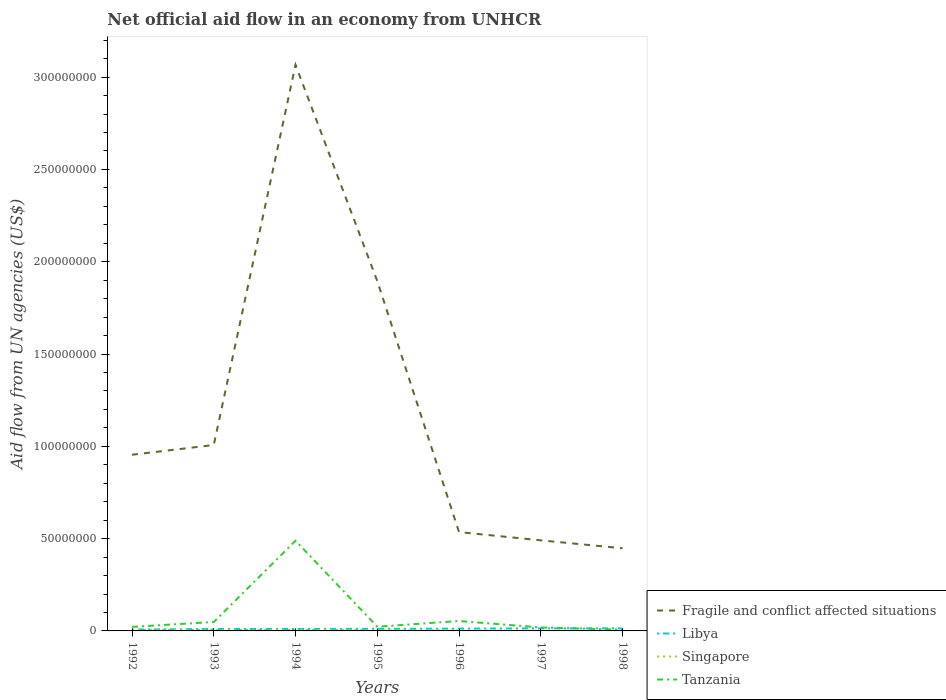Is the number of lines equal to the number of legend labels?
Your answer should be compact. Yes. Across all years, what is the maximum net official aid flow in Fragile and conflict affected situations?
Offer a very short reply. 4.48e+07. What is the total net official aid flow in Fragile and conflict affected situations in the graph?
Give a very brief answer. 4.19e+07. What is the difference between the highest and the second highest net official aid flow in Singapore?
Offer a terse response. 5.30e+05. Is the net official aid flow in Tanzania strictly greater than the net official aid flow in Singapore over the years?
Make the answer very short. No. How many lines are there?
Offer a very short reply. 4. Does the graph contain any zero values?
Make the answer very short. No. Does the graph contain grids?
Keep it short and to the point. No. How many legend labels are there?
Ensure brevity in your answer.  4. How are the legend labels stacked?
Keep it short and to the point. Vertical. What is the title of the graph?
Provide a succinct answer. Net official aid flow in an economy from UNHCR. What is the label or title of the X-axis?
Make the answer very short. Years. What is the label or title of the Y-axis?
Keep it short and to the point. Aid flow from UN agencies (US$). What is the Aid flow from UN agencies (US$) of Fragile and conflict affected situations in 1992?
Ensure brevity in your answer.  9.54e+07. What is the Aid flow from UN agencies (US$) in Libya in 1992?
Offer a terse response. 7.30e+05. What is the Aid flow from UN agencies (US$) in Singapore in 1992?
Your answer should be very brief. 6.00e+05. What is the Aid flow from UN agencies (US$) of Tanzania in 1992?
Ensure brevity in your answer.  2.19e+06. What is the Aid flow from UN agencies (US$) in Fragile and conflict affected situations in 1993?
Provide a succinct answer. 1.01e+08. What is the Aid flow from UN agencies (US$) in Libya in 1993?
Provide a short and direct response. 1.05e+06. What is the Aid flow from UN agencies (US$) in Tanzania in 1993?
Your answer should be compact. 4.85e+06. What is the Aid flow from UN agencies (US$) of Fragile and conflict affected situations in 1994?
Your answer should be compact. 3.07e+08. What is the Aid flow from UN agencies (US$) of Libya in 1994?
Your answer should be compact. 1.07e+06. What is the Aid flow from UN agencies (US$) of Singapore in 1994?
Keep it short and to the point. 5.80e+05. What is the Aid flow from UN agencies (US$) of Tanzania in 1994?
Offer a terse response. 4.89e+07. What is the Aid flow from UN agencies (US$) in Fragile and conflict affected situations in 1995?
Offer a very short reply. 1.90e+08. What is the Aid flow from UN agencies (US$) of Libya in 1995?
Your answer should be very brief. 1.13e+06. What is the Aid flow from UN agencies (US$) in Tanzania in 1995?
Provide a short and direct response. 2.28e+06. What is the Aid flow from UN agencies (US$) in Fragile and conflict affected situations in 1996?
Your answer should be very brief. 5.36e+07. What is the Aid flow from UN agencies (US$) of Libya in 1996?
Your response must be concise. 1.25e+06. What is the Aid flow from UN agencies (US$) in Tanzania in 1996?
Keep it short and to the point. 5.37e+06. What is the Aid flow from UN agencies (US$) in Fragile and conflict affected situations in 1997?
Make the answer very short. 4.91e+07. What is the Aid flow from UN agencies (US$) in Libya in 1997?
Ensure brevity in your answer.  1.38e+06. What is the Aid flow from UN agencies (US$) in Singapore in 1997?
Your answer should be compact. 7.00e+04. What is the Aid flow from UN agencies (US$) in Tanzania in 1997?
Ensure brevity in your answer.  1.87e+06. What is the Aid flow from UN agencies (US$) in Fragile and conflict affected situations in 1998?
Offer a terse response. 4.48e+07. What is the Aid flow from UN agencies (US$) in Libya in 1998?
Make the answer very short. 1.39e+06. What is the Aid flow from UN agencies (US$) of Singapore in 1998?
Make the answer very short. 7.00e+04. What is the Aid flow from UN agencies (US$) in Tanzania in 1998?
Offer a terse response. 6.90e+05. Across all years, what is the maximum Aid flow from UN agencies (US$) of Fragile and conflict affected situations?
Offer a terse response. 3.07e+08. Across all years, what is the maximum Aid flow from UN agencies (US$) of Libya?
Your answer should be very brief. 1.39e+06. Across all years, what is the maximum Aid flow from UN agencies (US$) in Tanzania?
Your answer should be very brief. 4.89e+07. Across all years, what is the minimum Aid flow from UN agencies (US$) of Fragile and conflict affected situations?
Provide a short and direct response. 4.48e+07. Across all years, what is the minimum Aid flow from UN agencies (US$) of Libya?
Your answer should be very brief. 7.30e+05. Across all years, what is the minimum Aid flow from UN agencies (US$) in Tanzania?
Your answer should be very brief. 6.90e+05. What is the total Aid flow from UN agencies (US$) of Fragile and conflict affected situations in the graph?
Offer a terse response. 8.40e+08. What is the total Aid flow from UN agencies (US$) of Singapore in the graph?
Your answer should be very brief. 2.29e+06. What is the total Aid flow from UN agencies (US$) in Tanzania in the graph?
Make the answer very short. 6.61e+07. What is the difference between the Aid flow from UN agencies (US$) of Fragile and conflict affected situations in 1992 and that in 1993?
Provide a short and direct response. -5.28e+06. What is the difference between the Aid flow from UN agencies (US$) of Libya in 1992 and that in 1993?
Your response must be concise. -3.20e+05. What is the difference between the Aid flow from UN agencies (US$) of Singapore in 1992 and that in 1993?
Give a very brief answer. 1.60e+05. What is the difference between the Aid flow from UN agencies (US$) in Tanzania in 1992 and that in 1993?
Your answer should be compact. -2.66e+06. What is the difference between the Aid flow from UN agencies (US$) in Fragile and conflict affected situations in 1992 and that in 1994?
Your answer should be compact. -2.11e+08. What is the difference between the Aid flow from UN agencies (US$) of Libya in 1992 and that in 1994?
Keep it short and to the point. -3.40e+05. What is the difference between the Aid flow from UN agencies (US$) in Tanzania in 1992 and that in 1994?
Your response must be concise. -4.67e+07. What is the difference between the Aid flow from UN agencies (US$) in Fragile and conflict affected situations in 1992 and that in 1995?
Your answer should be compact. -9.41e+07. What is the difference between the Aid flow from UN agencies (US$) of Libya in 1992 and that in 1995?
Your answer should be very brief. -4.00e+05. What is the difference between the Aid flow from UN agencies (US$) in Fragile and conflict affected situations in 1992 and that in 1996?
Ensure brevity in your answer.  4.19e+07. What is the difference between the Aid flow from UN agencies (US$) of Libya in 1992 and that in 1996?
Provide a short and direct response. -5.20e+05. What is the difference between the Aid flow from UN agencies (US$) of Singapore in 1992 and that in 1996?
Ensure brevity in your answer.  3.70e+05. What is the difference between the Aid flow from UN agencies (US$) of Tanzania in 1992 and that in 1996?
Your answer should be compact. -3.18e+06. What is the difference between the Aid flow from UN agencies (US$) in Fragile and conflict affected situations in 1992 and that in 1997?
Provide a short and direct response. 4.64e+07. What is the difference between the Aid flow from UN agencies (US$) in Libya in 1992 and that in 1997?
Your answer should be compact. -6.50e+05. What is the difference between the Aid flow from UN agencies (US$) of Singapore in 1992 and that in 1997?
Your response must be concise. 5.30e+05. What is the difference between the Aid flow from UN agencies (US$) of Tanzania in 1992 and that in 1997?
Provide a short and direct response. 3.20e+05. What is the difference between the Aid flow from UN agencies (US$) in Fragile and conflict affected situations in 1992 and that in 1998?
Your answer should be very brief. 5.07e+07. What is the difference between the Aid flow from UN agencies (US$) in Libya in 1992 and that in 1998?
Offer a very short reply. -6.60e+05. What is the difference between the Aid flow from UN agencies (US$) of Singapore in 1992 and that in 1998?
Your answer should be very brief. 5.30e+05. What is the difference between the Aid flow from UN agencies (US$) of Tanzania in 1992 and that in 1998?
Provide a succinct answer. 1.50e+06. What is the difference between the Aid flow from UN agencies (US$) of Fragile and conflict affected situations in 1993 and that in 1994?
Offer a very short reply. -2.06e+08. What is the difference between the Aid flow from UN agencies (US$) of Libya in 1993 and that in 1994?
Provide a short and direct response. -2.00e+04. What is the difference between the Aid flow from UN agencies (US$) of Tanzania in 1993 and that in 1994?
Offer a very short reply. -4.40e+07. What is the difference between the Aid flow from UN agencies (US$) in Fragile and conflict affected situations in 1993 and that in 1995?
Provide a short and direct response. -8.88e+07. What is the difference between the Aid flow from UN agencies (US$) of Libya in 1993 and that in 1995?
Give a very brief answer. -8.00e+04. What is the difference between the Aid flow from UN agencies (US$) of Tanzania in 1993 and that in 1995?
Provide a succinct answer. 2.57e+06. What is the difference between the Aid flow from UN agencies (US$) in Fragile and conflict affected situations in 1993 and that in 1996?
Provide a short and direct response. 4.72e+07. What is the difference between the Aid flow from UN agencies (US$) of Tanzania in 1993 and that in 1996?
Your answer should be compact. -5.20e+05. What is the difference between the Aid flow from UN agencies (US$) in Fragile and conflict affected situations in 1993 and that in 1997?
Offer a very short reply. 5.16e+07. What is the difference between the Aid flow from UN agencies (US$) in Libya in 1993 and that in 1997?
Your answer should be very brief. -3.30e+05. What is the difference between the Aid flow from UN agencies (US$) in Tanzania in 1993 and that in 1997?
Provide a short and direct response. 2.98e+06. What is the difference between the Aid flow from UN agencies (US$) in Fragile and conflict affected situations in 1993 and that in 1998?
Your answer should be very brief. 5.60e+07. What is the difference between the Aid flow from UN agencies (US$) of Singapore in 1993 and that in 1998?
Provide a succinct answer. 3.70e+05. What is the difference between the Aid flow from UN agencies (US$) of Tanzania in 1993 and that in 1998?
Offer a very short reply. 4.16e+06. What is the difference between the Aid flow from UN agencies (US$) of Fragile and conflict affected situations in 1994 and that in 1995?
Your answer should be compact. 1.17e+08. What is the difference between the Aid flow from UN agencies (US$) in Tanzania in 1994 and that in 1995?
Give a very brief answer. 4.66e+07. What is the difference between the Aid flow from UN agencies (US$) of Fragile and conflict affected situations in 1994 and that in 1996?
Ensure brevity in your answer.  2.53e+08. What is the difference between the Aid flow from UN agencies (US$) of Libya in 1994 and that in 1996?
Provide a short and direct response. -1.80e+05. What is the difference between the Aid flow from UN agencies (US$) of Singapore in 1994 and that in 1996?
Your response must be concise. 3.50e+05. What is the difference between the Aid flow from UN agencies (US$) in Tanzania in 1994 and that in 1996?
Keep it short and to the point. 4.35e+07. What is the difference between the Aid flow from UN agencies (US$) of Fragile and conflict affected situations in 1994 and that in 1997?
Keep it short and to the point. 2.58e+08. What is the difference between the Aid flow from UN agencies (US$) of Libya in 1994 and that in 1997?
Make the answer very short. -3.10e+05. What is the difference between the Aid flow from UN agencies (US$) in Singapore in 1994 and that in 1997?
Your answer should be very brief. 5.10e+05. What is the difference between the Aid flow from UN agencies (US$) in Tanzania in 1994 and that in 1997?
Your answer should be compact. 4.70e+07. What is the difference between the Aid flow from UN agencies (US$) of Fragile and conflict affected situations in 1994 and that in 1998?
Your response must be concise. 2.62e+08. What is the difference between the Aid flow from UN agencies (US$) of Libya in 1994 and that in 1998?
Offer a very short reply. -3.20e+05. What is the difference between the Aid flow from UN agencies (US$) of Singapore in 1994 and that in 1998?
Ensure brevity in your answer.  5.10e+05. What is the difference between the Aid flow from UN agencies (US$) of Tanzania in 1994 and that in 1998?
Your response must be concise. 4.82e+07. What is the difference between the Aid flow from UN agencies (US$) in Fragile and conflict affected situations in 1995 and that in 1996?
Provide a short and direct response. 1.36e+08. What is the difference between the Aid flow from UN agencies (US$) in Libya in 1995 and that in 1996?
Ensure brevity in your answer.  -1.20e+05. What is the difference between the Aid flow from UN agencies (US$) of Tanzania in 1995 and that in 1996?
Offer a very short reply. -3.09e+06. What is the difference between the Aid flow from UN agencies (US$) in Fragile and conflict affected situations in 1995 and that in 1997?
Provide a succinct answer. 1.40e+08. What is the difference between the Aid flow from UN agencies (US$) in Singapore in 1995 and that in 1997?
Your answer should be very brief. 2.30e+05. What is the difference between the Aid flow from UN agencies (US$) of Tanzania in 1995 and that in 1997?
Your answer should be very brief. 4.10e+05. What is the difference between the Aid flow from UN agencies (US$) of Fragile and conflict affected situations in 1995 and that in 1998?
Keep it short and to the point. 1.45e+08. What is the difference between the Aid flow from UN agencies (US$) in Tanzania in 1995 and that in 1998?
Your answer should be very brief. 1.59e+06. What is the difference between the Aid flow from UN agencies (US$) of Fragile and conflict affected situations in 1996 and that in 1997?
Ensure brevity in your answer.  4.48e+06. What is the difference between the Aid flow from UN agencies (US$) of Singapore in 1996 and that in 1997?
Offer a very short reply. 1.60e+05. What is the difference between the Aid flow from UN agencies (US$) of Tanzania in 1996 and that in 1997?
Keep it short and to the point. 3.50e+06. What is the difference between the Aid flow from UN agencies (US$) in Fragile and conflict affected situations in 1996 and that in 1998?
Make the answer very short. 8.78e+06. What is the difference between the Aid flow from UN agencies (US$) in Tanzania in 1996 and that in 1998?
Provide a succinct answer. 4.68e+06. What is the difference between the Aid flow from UN agencies (US$) in Fragile and conflict affected situations in 1997 and that in 1998?
Provide a short and direct response. 4.30e+06. What is the difference between the Aid flow from UN agencies (US$) in Libya in 1997 and that in 1998?
Ensure brevity in your answer.  -10000. What is the difference between the Aid flow from UN agencies (US$) of Singapore in 1997 and that in 1998?
Provide a short and direct response. 0. What is the difference between the Aid flow from UN agencies (US$) of Tanzania in 1997 and that in 1998?
Your answer should be very brief. 1.18e+06. What is the difference between the Aid flow from UN agencies (US$) in Fragile and conflict affected situations in 1992 and the Aid flow from UN agencies (US$) in Libya in 1993?
Provide a short and direct response. 9.44e+07. What is the difference between the Aid flow from UN agencies (US$) in Fragile and conflict affected situations in 1992 and the Aid flow from UN agencies (US$) in Singapore in 1993?
Keep it short and to the point. 9.50e+07. What is the difference between the Aid flow from UN agencies (US$) of Fragile and conflict affected situations in 1992 and the Aid flow from UN agencies (US$) of Tanzania in 1993?
Give a very brief answer. 9.06e+07. What is the difference between the Aid flow from UN agencies (US$) of Libya in 1992 and the Aid flow from UN agencies (US$) of Tanzania in 1993?
Make the answer very short. -4.12e+06. What is the difference between the Aid flow from UN agencies (US$) in Singapore in 1992 and the Aid flow from UN agencies (US$) in Tanzania in 1993?
Your answer should be very brief. -4.25e+06. What is the difference between the Aid flow from UN agencies (US$) in Fragile and conflict affected situations in 1992 and the Aid flow from UN agencies (US$) in Libya in 1994?
Provide a short and direct response. 9.44e+07. What is the difference between the Aid flow from UN agencies (US$) in Fragile and conflict affected situations in 1992 and the Aid flow from UN agencies (US$) in Singapore in 1994?
Make the answer very short. 9.49e+07. What is the difference between the Aid flow from UN agencies (US$) of Fragile and conflict affected situations in 1992 and the Aid flow from UN agencies (US$) of Tanzania in 1994?
Provide a short and direct response. 4.66e+07. What is the difference between the Aid flow from UN agencies (US$) in Libya in 1992 and the Aid flow from UN agencies (US$) in Singapore in 1994?
Offer a terse response. 1.50e+05. What is the difference between the Aid flow from UN agencies (US$) in Libya in 1992 and the Aid flow from UN agencies (US$) in Tanzania in 1994?
Your answer should be very brief. -4.81e+07. What is the difference between the Aid flow from UN agencies (US$) of Singapore in 1992 and the Aid flow from UN agencies (US$) of Tanzania in 1994?
Make the answer very short. -4.83e+07. What is the difference between the Aid flow from UN agencies (US$) of Fragile and conflict affected situations in 1992 and the Aid flow from UN agencies (US$) of Libya in 1995?
Your answer should be very brief. 9.43e+07. What is the difference between the Aid flow from UN agencies (US$) in Fragile and conflict affected situations in 1992 and the Aid flow from UN agencies (US$) in Singapore in 1995?
Keep it short and to the point. 9.51e+07. What is the difference between the Aid flow from UN agencies (US$) in Fragile and conflict affected situations in 1992 and the Aid flow from UN agencies (US$) in Tanzania in 1995?
Keep it short and to the point. 9.32e+07. What is the difference between the Aid flow from UN agencies (US$) in Libya in 1992 and the Aid flow from UN agencies (US$) in Singapore in 1995?
Offer a terse response. 4.30e+05. What is the difference between the Aid flow from UN agencies (US$) in Libya in 1992 and the Aid flow from UN agencies (US$) in Tanzania in 1995?
Your answer should be very brief. -1.55e+06. What is the difference between the Aid flow from UN agencies (US$) of Singapore in 1992 and the Aid flow from UN agencies (US$) of Tanzania in 1995?
Offer a terse response. -1.68e+06. What is the difference between the Aid flow from UN agencies (US$) in Fragile and conflict affected situations in 1992 and the Aid flow from UN agencies (US$) in Libya in 1996?
Your answer should be very brief. 9.42e+07. What is the difference between the Aid flow from UN agencies (US$) in Fragile and conflict affected situations in 1992 and the Aid flow from UN agencies (US$) in Singapore in 1996?
Your response must be concise. 9.52e+07. What is the difference between the Aid flow from UN agencies (US$) in Fragile and conflict affected situations in 1992 and the Aid flow from UN agencies (US$) in Tanzania in 1996?
Offer a terse response. 9.01e+07. What is the difference between the Aid flow from UN agencies (US$) of Libya in 1992 and the Aid flow from UN agencies (US$) of Tanzania in 1996?
Offer a very short reply. -4.64e+06. What is the difference between the Aid flow from UN agencies (US$) of Singapore in 1992 and the Aid flow from UN agencies (US$) of Tanzania in 1996?
Provide a succinct answer. -4.77e+06. What is the difference between the Aid flow from UN agencies (US$) in Fragile and conflict affected situations in 1992 and the Aid flow from UN agencies (US$) in Libya in 1997?
Offer a terse response. 9.41e+07. What is the difference between the Aid flow from UN agencies (US$) of Fragile and conflict affected situations in 1992 and the Aid flow from UN agencies (US$) of Singapore in 1997?
Your answer should be compact. 9.54e+07. What is the difference between the Aid flow from UN agencies (US$) in Fragile and conflict affected situations in 1992 and the Aid flow from UN agencies (US$) in Tanzania in 1997?
Provide a succinct answer. 9.36e+07. What is the difference between the Aid flow from UN agencies (US$) of Libya in 1992 and the Aid flow from UN agencies (US$) of Singapore in 1997?
Provide a succinct answer. 6.60e+05. What is the difference between the Aid flow from UN agencies (US$) of Libya in 1992 and the Aid flow from UN agencies (US$) of Tanzania in 1997?
Your answer should be compact. -1.14e+06. What is the difference between the Aid flow from UN agencies (US$) of Singapore in 1992 and the Aid flow from UN agencies (US$) of Tanzania in 1997?
Offer a terse response. -1.27e+06. What is the difference between the Aid flow from UN agencies (US$) in Fragile and conflict affected situations in 1992 and the Aid flow from UN agencies (US$) in Libya in 1998?
Offer a very short reply. 9.40e+07. What is the difference between the Aid flow from UN agencies (US$) in Fragile and conflict affected situations in 1992 and the Aid flow from UN agencies (US$) in Singapore in 1998?
Provide a short and direct response. 9.54e+07. What is the difference between the Aid flow from UN agencies (US$) of Fragile and conflict affected situations in 1992 and the Aid flow from UN agencies (US$) of Tanzania in 1998?
Ensure brevity in your answer.  9.48e+07. What is the difference between the Aid flow from UN agencies (US$) in Libya in 1992 and the Aid flow from UN agencies (US$) in Tanzania in 1998?
Keep it short and to the point. 4.00e+04. What is the difference between the Aid flow from UN agencies (US$) of Fragile and conflict affected situations in 1993 and the Aid flow from UN agencies (US$) of Libya in 1994?
Ensure brevity in your answer.  9.96e+07. What is the difference between the Aid flow from UN agencies (US$) in Fragile and conflict affected situations in 1993 and the Aid flow from UN agencies (US$) in Singapore in 1994?
Ensure brevity in your answer.  1.00e+08. What is the difference between the Aid flow from UN agencies (US$) in Fragile and conflict affected situations in 1993 and the Aid flow from UN agencies (US$) in Tanzania in 1994?
Ensure brevity in your answer.  5.18e+07. What is the difference between the Aid flow from UN agencies (US$) of Libya in 1993 and the Aid flow from UN agencies (US$) of Tanzania in 1994?
Your response must be concise. -4.78e+07. What is the difference between the Aid flow from UN agencies (US$) in Singapore in 1993 and the Aid flow from UN agencies (US$) in Tanzania in 1994?
Offer a very short reply. -4.84e+07. What is the difference between the Aid flow from UN agencies (US$) of Fragile and conflict affected situations in 1993 and the Aid flow from UN agencies (US$) of Libya in 1995?
Offer a very short reply. 9.96e+07. What is the difference between the Aid flow from UN agencies (US$) in Fragile and conflict affected situations in 1993 and the Aid flow from UN agencies (US$) in Singapore in 1995?
Keep it short and to the point. 1.00e+08. What is the difference between the Aid flow from UN agencies (US$) of Fragile and conflict affected situations in 1993 and the Aid flow from UN agencies (US$) of Tanzania in 1995?
Give a very brief answer. 9.84e+07. What is the difference between the Aid flow from UN agencies (US$) of Libya in 1993 and the Aid flow from UN agencies (US$) of Singapore in 1995?
Provide a succinct answer. 7.50e+05. What is the difference between the Aid flow from UN agencies (US$) in Libya in 1993 and the Aid flow from UN agencies (US$) in Tanzania in 1995?
Keep it short and to the point. -1.23e+06. What is the difference between the Aid flow from UN agencies (US$) in Singapore in 1993 and the Aid flow from UN agencies (US$) in Tanzania in 1995?
Your response must be concise. -1.84e+06. What is the difference between the Aid flow from UN agencies (US$) in Fragile and conflict affected situations in 1993 and the Aid flow from UN agencies (US$) in Libya in 1996?
Offer a very short reply. 9.95e+07. What is the difference between the Aid flow from UN agencies (US$) in Fragile and conflict affected situations in 1993 and the Aid flow from UN agencies (US$) in Singapore in 1996?
Your response must be concise. 1.00e+08. What is the difference between the Aid flow from UN agencies (US$) of Fragile and conflict affected situations in 1993 and the Aid flow from UN agencies (US$) of Tanzania in 1996?
Provide a succinct answer. 9.54e+07. What is the difference between the Aid flow from UN agencies (US$) in Libya in 1993 and the Aid flow from UN agencies (US$) in Singapore in 1996?
Give a very brief answer. 8.20e+05. What is the difference between the Aid flow from UN agencies (US$) of Libya in 1993 and the Aid flow from UN agencies (US$) of Tanzania in 1996?
Your response must be concise. -4.32e+06. What is the difference between the Aid flow from UN agencies (US$) in Singapore in 1993 and the Aid flow from UN agencies (US$) in Tanzania in 1996?
Ensure brevity in your answer.  -4.93e+06. What is the difference between the Aid flow from UN agencies (US$) of Fragile and conflict affected situations in 1993 and the Aid flow from UN agencies (US$) of Libya in 1997?
Your answer should be compact. 9.93e+07. What is the difference between the Aid flow from UN agencies (US$) in Fragile and conflict affected situations in 1993 and the Aid flow from UN agencies (US$) in Singapore in 1997?
Ensure brevity in your answer.  1.01e+08. What is the difference between the Aid flow from UN agencies (US$) in Fragile and conflict affected situations in 1993 and the Aid flow from UN agencies (US$) in Tanzania in 1997?
Keep it short and to the point. 9.88e+07. What is the difference between the Aid flow from UN agencies (US$) in Libya in 1993 and the Aid flow from UN agencies (US$) in Singapore in 1997?
Keep it short and to the point. 9.80e+05. What is the difference between the Aid flow from UN agencies (US$) of Libya in 1993 and the Aid flow from UN agencies (US$) of Tanzania in 1997?
Your answer should be compact. -8.20e+05. What is the difference between the Aid flow from UN agencies (US$) of Singapore in 1993 and the Aid flow from UN agencies (US$) of Tanzania in 1997?
Make the answer very short. -1.43e+06. What is the difference between the Aid flow from UN agencies (US$) in Fragile and conflict affected situations in 1993 and the Aid flow from UN agencies (US$) in Libya in 1998?
Offer a terse response. 9.93e+07. What is the difference between the Aid flow from UN agencies (US$) in Fragile and conflict affected situations in 1993 and the Aid flow from UN agencies (US$) in Singapore in 1998?
Your answer should be very brief. 1.01e+08. What is the difference between the Aid flow from UN agencies (US$) of Fragile and conflict affected situations in 1993 and the Aid flow from UN agencies (US$) of Tanzania in 1998?
Keep it short and to the point. 1.00e+08. What is the difference between the Aid flow from UN agencies (US$) in Libya in 1993 and the Aid flow from UN agencies (US$) in Singapore in 1998?
Your answer should be very brief. 9.80e+05. What is the difference between the Aid flow from UN agencies (US$) in Fragile and conflict affected situations in 1994 and the Aid flow from UN agencies (US$) in Libya in 1995?
Give a very brief answer. 3.06e+08. What is the difference between the Aid flow from UN agencies (US$) of Fragile and conflict affected situations in 1994 and the Aid flow from UN agencies (US$) of Singapore in 1995?
Keep it short and to the point. 3.06e+08. What is the difference between the Aid flow from UN agencies (US$) in Fragile and conflict affected situations in 1994 and the Aid flow from UN agencies (US$) in Tanzania in 1995?
Provide a short and direct response. 3.04e+08. What is the difference between the Aid flow from UN agencies (US$) in Libya in 1994 and the Aid flow from UN agencies (US$) in Singapore in 1995?
Ensure brevity in your answer.  7.70e+05. What is the difference between the Aid flow from UN agencies (US$) in Libya in 1994 and the Aid flow from UN agencies (US$) in Tanzania in 1995?
Your answer should be very brief. -1.21e+06. What is the difference between the Aid flow from UN agencies (US$) of Singapore in 1994 and the Aid flow from UN agencies (US$) of Tanzania in 1995?
Offer a terse response. -1.70e+06. What is the difference between the Aid flow from UN agencies (US$) of Fragile and conflict affected situations in 1994 and the Aid flow from UN agencies (US$) of Libya in 1996?
Keep it short and to the point. 3.05e+08. What is the difference between the Aid flow from UN agencies (US$) of Fragile and conflict affected situations in 1994 and the Aid flow from UN agencies (US$) of Singapore in 1996?
Keep it short and to the point. 3.06e+08. What is the difference between the Aid flow from UN agencies (US$) in Fragile and conflict affected situations in 1994 and the Aid flow from UN agencies (US$) in Tanzania in 1996?
Offer a very short reply. 3.01e+08. What is the difference between the Aid flow from UN agencies (US$) in Libya in 1994 and the Aid flow from UN agencies (US$) in Singapore in 1996?
Offer a terse response. 8.40e+05. What is the difference between the Aid flow from UN agencies (US$) in Libya in 1994 and the Aid flow from UN agencies (US$) in Tanzania in 1996?
Keep it short and to the point. -4.30e+06. What is the difference between the Aid flow from UN agencies (US$) of Singapore in 1994 and the Aid flow from UN agencies (US$) of Tanzania in 1996?
Ensure brevity in your answer.  -4.79e+06. What is the difference between the Aid flow from UN agencies (US$) of Fragile and conflict affected situations in 1994 and the Aid flow from UN agencies (US$) of Libya in 1997?
Ensure brevity in your answer.  3.05e+08. What is the difference between the Aid flow from UN agencies (US$) of Fragile and conflict affected situations in 1994 and the Aid flow from UN agencies (US$) of Singapore in 1997?
Keep it short and to the point. 3.07e+08. What is the difference between the Aid flow from UN agencies (US$) in Fragile and conflict affected situations in 1994 and the Aid flow from UN agencies (US$) in Tanzania in 1997?
Offer a very short reply. 3.05e+08. What is the difference between the Aid flow from UN agencies (US$) of Libya in 1994 and the Aid flow from UN agencies (US$) of Singapore in 1997?
Your answer should be very brief. 1.00e+06. What is the difference between the Aid flow from UN agencies (US$) of Libya in 1994 and the Aid flow from UN agencies (US$) of Tanzania in 1997?
Make the answer very short. -8.00e+05. What is the difference between the Aid flow from UN agencies (US$) in Singapore in 1994 and the Aid flow from UN agencies (US$) in Tanzania in 1997?
Ensure brevity in your answer.  -1.29e+06. What is the difference between the Aid flow from UN agencies (US$) of Fragile and conflict affected situations in 1994 and the Aid flow from UN agencies (US$) of Libya in 1998?
Your answer should be compact. 3.05e+08. What is the difference between the Aid flow from UN agencies (US$) of Fragile and conflict affected situations in 1994 and the Aid flow from UN agencies (US$) of Singapore in 1998?
Make the answer very short. 3.07e+08. What is the difference between the Aid flow from UN agencies (US$) in Fragile and conflict affected situations in 1994 and the Aid flow from UN agencies (US$) in Tanzania in 1998?
Keep it short and to the point. 3.06e+08. What is the difference between the Aid flow from UN agencies (US$) of Libya in 1994 and the Aid flow from UN agencies (US$) of Singapore in 1998?
Provide a short and direct response. 1.00e+06. What is the difference between the Aid flow from UN agencies (US$) in Libya in 1994 and the Aid flow from UN agencies (US$) in Tanzania in 1998?
Your response must be concise. 3.80e+05. What is the difference between the Aid flow from UN agencies (US$) of Singapore in 1994 and the Aid flow from UN agencies (US$) of Tanzania in 1998?
Provide a short and direct response. -1.10e+05. What is the difference between the Aid flow from UN agencies (US$) of Fragile and conflict affected situations in 1995 and the Aid flow from UN agencies (US$) of Libya in 1996?
Make the answer very short. 1.88e+08. What is the difference between the Aid flow from UN agencies (US$) of Fragile and conflict affected situations in 1995 and the Aid flow from UN agencies (US$) of Singapore in 1996?
Provide a succinct answer. 1.89e+08. What is the difference between the Aid flow from UN agencies (US$) in Fragile and conflict affected situations in 1995 and the Aid flow from UN agencies (US$) in Tanzania in 1996?
Make the answer very short. 1.84e+08. What is the difference between the Aid flow from UN agencies (US$) of Libya in 1995 and the Aid flow from UN agencies (US$) of Tanzania in 1996?
Ensure brevity in your answer.  -4.24e+06. What is the difference between the Aid flow from UN agencies (US$) in Singapore in 1995 and the Aid flow from UN agencies (US$) in Tanzania in 1996?
Offer a very short reply. -5.07e+06. What is the difference between the Aid flow from UN agencies (US$) of Fragile and conflict affected situations in 1995 and the Aid flow from UN agencies (US$) of Libya in 1997?
Your response must be concise. 1.88e+08. What is the difference between the Aid flow from UN agencies (US$) of Fragile and conflict affected situations in 1995 and the Aid flow from UN agencies (US$) of Singapore in 1997?
Your answer should be compact. 1.89e+08. What is the difference between the Aid flow from UN agencies (US$) of Fragile and conflict affected situations in 1995 and the Aid flow from UN agencies (US$) of Tanzania in 1997?
Your response must be concise. 1.88e+08. What is the difference between the Aid flow from UN agencies (US$) of Libya in 1995 and the Aid flow from UN agencies (US$) of Singapore in 1997?
Provide a short and direct response. 1.06e+06. What is the difference between the Aid flow from UN agencies (US$) of Libya in 1995 and the Aid flow from UN agencies (US$) of Tanzania in 1997?
Make the answer very short. -7.40e+05. What is the difference between the Aid flow from UN agencies (US$) in Singapore in 1995 and the Aid flow from UN agencies (US$) in Tanzania in 1997?
Offer a terse response. -1.57e+06. What is the difference between the Aid flow from UN agencies (US$) in Fragile and conflict affected situations in 1995 and the Aid flow from UN agencies (US$) in Libya in 1998?
Provide a succinct answer. 1.88e+08. What is the difference between the Aid flow from UN agencies (US$) of Fragile and conflict affected situations in 1995 and the Aid flow from UN agencies (US$) of Singapore in 1998?
Give a very brief answer. 1.89e+08. What is the difference between the Aid flow from UN agencies (US$) in Fragile and conflict affected situations in 1995 and the Aid flow from UN agencies (US$) in Tanzania in 1998?
Offer a very short reply. 1.89e+08. What is the difference between the Aid flow from UN agencies (US$) in Libya in 1995 and the Aid flow from UN agencies (US$) in Singapore in 1998?
Your response must be concise. 1.06e+06. What is the difference between the Aid flow from UN agencies (US$) of Singapore in 1995 and the Aid flow from UN agencies (US$) of Tanzania in 1998?
Give a very brief answer. -3.90e+05. What is the difference between the Aid flow from UN agencies (US$) of Fragile and conflict affected situations in 1996 and the Aid flow from UN agencies (US$) of Libya in 1997?
Keep it short and to the point. 5.22e+07. What is the difference between the Aid flow from UN agencies (US$) of Fragile and conflict affected situations in 1996 and the Aid flow from UN agencies (US$) of Singapore in 1997?
Offer a terse response. 5.35e+07. What is the difference between the Aid flow from UN agencies (US$) in Fragile and conflict affected situations in 1996 and the Aid flow from UN agencies (US$) in Tanzania in 1997?
Provide a succinct answer. 5.17e+07. What is the difference between the Aid flow from UN agencies (US$) of Libya in 1996 and the Aid flow from UN agencies (US$) of Singapore in 1997?
Your response must be concise. 1.18e+06. What is the difference between the Aid flow from UN agencies (US$) in Libya in 1996 and the Aid flow from UN agencies (US$) in Tanzania in 1997?
Your answer should be compact. -6.20e+05. What is the difference between the Aid flow from UN agencies (US$) in Singapore in 1996 and the Aid flow from UN agencies (US$) in Tanzania in 1997?
Ensure brevity in your answer.  -1.64e+06. What is the difference between the Aid flow from UN agencies (US$) of Fragile and conflict affected situations in 1996 and the Aid flow from UN agencies (US$) of Libya in 1998?
Keep it short and to the point. 5.22e+07. What is the difference between the Aid flow from UN agencies (US$) of Fragile and conflict affected situations in 1996 and the Aid flow from UN agencies (US$) of Singapore in 1998?
Offer a terse response. 5.35e+07. What is the difference between the Aid flow from UN agencies (US$) of Fragile and conflict affected situations in 1996 and the Aid flow from UN agencies (US$) of Tanzania in 1998?
Provide a short and direct response. 5.29e+07. What is the difference between the Aid flow from UN agencies (US$) of Libya in 1996 and the Aid flow from UN agencies (US$) of Singapore in 1998?
Offer a terse response. 1.18e+06. What is the difference between the Aid flow from UN agencies (US$) in Libya in 1996 and the Aid flow from UN agencies (US$) in Tanzania in 1998?
Your response must be concise. 5.60e+05. What is the difference between the Aid flow from UN agencies (US$) in Singapore in 1996 and the Aid flow from UN agencies (US$) in Tanzania in 1998?
Keep it short and to the point. -4.60e+05. What is the difference between the Aid flow from UN agencies (US$) in Fragile and conflict affected situations in 1997 and the Aid flow from UN agencies (US$) in Libya in 1998?
Make the answer very short. 4.77e+07. What is the difference between the Aid flow from UN agencies (US$) of Fragile and conflict affected situations in 1997 and the Aid flow from UN agencies (US$) of Singapore in 1998?
Offer a terse response. 4.90e+07. What is the difference between the Aid flow from UN agencies (US$) of Fragile and conflict affected situations in 1997 and the Aid flow from UN agencies (US$) of Tanzania in 1998?
Your answer should be very brief. 4.84e+07. What is the difference between the Aid flow from UN agencies (US$) of Libya in 1997 and the Aid flow from UN agencies (US$) of Singapore in 1998?
Provide a succinct answer. 1.31e+06. What is the difference between the Aid flow from UN agencies (US$) in Libya in 1997 and the Aid flow from UN agencies (US$) in Tanzania in 1998?
Give a very brief answer. 6.90e+05. What is the difference between the Aid flow from UN agencies (US$) of Singapore in 1997 and the Aid flow from UN agencies (US$) of Tanzania in 1998?
Your answer should be very brief. -6.20e+05. What is the average Aid flow from UN agencies (US$) in Fragile and conflict affected situations per year?
Ensure brevity in your answer.  1.20e+08. What is the average Aid flow from UN agencies (US$) of Libya per year?
Keep it short and to the point. 1.14e+06. What is the average Aid flow from UN agencies (US$) of Singapore per year?
Your answer should be very brief. 3.27e+05. What is the average Aid flow from UN agencies (US$) in Tanzania per year?
Ensure brevity in your answer.  9.45e+06. In the year 1992, what is the difference between the Aid flow from UN agencies (US$) of Fragile and conflict affected situations and Aid flow from UN agencies (US$) of Libya?
Offer a terse response. 9.47e+07. In the year 1992, what is the difference between the Aid flow from UN agencies (US$) of Fragile and conflict affected situations and Aid flow from UN agencies (US$) of Singapore?
Your answer should be compact. 9.48e+07. In the year 1992, what is the difference between the Aid flow from UN agencies (US$) in Fragile and conflict affected situations and Aid flow from UN agencies (US$) in Tanzania?
Offer a terse response. 9.32e+07. In the year 1992, what is the difference between the Aid flow from UN agencies (US$) of Libya and Aid flow from UN agencies (US$) of Singapore?
Provide a short and direct response. 1.30e+05. In the year 1992, what is the difference between the Aid flow from UN agencies (US$) of Libya and Aid flow from UN agencies (US$) of Tanzania?
Keep it short and to the point. -1.46e+06. In the year 1992, what is the difference between the Aid flow from UN agencies (US$) of Singapore and Aid flow from UN agencies (US$) of Tanzania?
Make the answer very short. -1.59e+06. In the year 1993, what is the difference between the Aid flow from UN agencies (US$) in Fragile and conflict affected situations and Aid flow from UN agencies (US$) in Libya?
Give a very brief answer. 9.97e+07. In the year 1993, what is the difference between the Aid flow from UN agencies (US$) in Fragile and conflict affected situations and Aid flow from UN agencies (US$) in Singapore?
Provide a succinct answer. 1.00e+08. In the year 1993, what is the difference between the Aid flow from UN agencies (US$) of Fragile and conflict affected situations and Aid flow from UN agencies (US$) of Tanzania?
Offer a very short reply. 9.59e+07. In the year 1993, what is the difference between the Aid flow from UN agencies (US$) of Libya and Aid flow from UN agencies (US$) of Tanzania?
Your answer should be compact. -3.80e+06. In the year 1993, what is the difference between the Aid flow from UN agencies (US$) of Singapore and Aid flow from UN agencies (US$) of Tanzania?
Offer a terse response. -4.41e+06. In the year 1994, what is the difference between the Aid flow from UN agencies (US$) in Fragile and conflict affected situations and Aid flow from UN agencies (US$) in Libya?
Your answer should be very brief. 3.06e+08. In the year 1994, what is the difference between the Aid flow from UN agencies (US$) in Fragile and conflict affected situations and Aid flow from UN agencies (US$) in Singapore?
Ensure brevity in your answer.  3.06e+08. In the year 1994, what is the difference between the Aid flow from UN agencies (US$) of Fragile and conflict affected situations and Aid flow from UN agencies (US$) of Tanzania?
Ensure brevity in your answer.  2.58e+08. In the year 1994, what is the difference between the Aid flow from UN agencies (US$) in Libya and Aid flow from UN agencies (US$) in Tanzania?
Provide a succinct answer. -4.78e+07. In the year 1994, what is the difference between the Aid flow from UN agencies (US$) in Singapore and Aid flow from UN agencies (US$) in Tanzania?
Keep it short and to the point. -4.83e+07. In the year 1995, what is the difference between the Aid flow from UN agencies (US$) of Fragile and conflict affected situations and Aid flow from UN agencies (US$) of Libya?
Provide a short and direct response. 1.88e+08. In the year 1995, what is the difference between the Aid flow from UN agencies (US$) of Fragile and conflict affected situations and Aid flow from UN agencies (US$) of Singapore?
Offer a very short reply. 1.89e+08. In the year 1995, what is the difference between the Aid flow from UN agencies (US$) in Fragile and conflict affected situations and Aid flow from UN agencies (US$) in Tanzania?
Provide a succinct answer. 1.87e+08. In the year 1995, what is the difference between the Aid flow from UN agencies (US$) of Libya and Aid flow from UN agencies (US$) of Singapore?
Ensure brevity in your answer.  8.30e+05. In the year 1995, what is the difference between the Aid flow from UN agencies (US$) of Libya and Aid flow from UN agencies (US$) of Tanzania?
Ensure brevity in your answer.  -1.15e+06. In the year 1995, what is the difference between the Aid flow from UN agencies (US$) of Singapore and Aid flow from UN agencies (US$) of Tanzania?
Offer a very short reply. -1.98e+06. In the year 1996, what is the difference between the Aid flow from UN agencies (US$) in Fragile and conflict affected situations and Aid flow from UN agencies (US$) in Libya?
Keep it short and to the point. 5.23e+07. In the year 1996, what is the difference between the Aid flow from UN agencies (US$) of Fragile and conflict affected situations and Aid flow from UN agencies (US$) of Singapore?
Your answer should be compact. 5.33e+07. In the year 1996, what is the difference between the Aid flow from UN agencies (US$) in Fragile and conflict affected situations and Aid flow from UN agencies (US$) in Tanzania?
Make the answer very short. 4.82e+07. In the year 1996, what is the difference between the Aid flow from UN agencies (US$) of Libya and Aid flow from UN agencies (US$) of Singapore?
Your response must be concise. 1.02e+06. In the year 1996, what is the difference between the Aid flow from UN agencies (US$) in Libya and Aid flow from UN agencies (US$) in Tanzania?
Make the answer very short. -4.12e+06. In the year 1996, what is the difference between the Aid flow from UN agencies (US$) of Singapore and Aid flow from UN agencies (US$) of Tanzania?
Offer a very short reply. -5.14e+06. In the year 1997, what is the difference between the Aid flow from UN agencies (US$) in Fragile and conflict affected situations and Aid flow from UN agencies (US$) in Libya?
Give a very brief answer. 4.77e+07. In the year 1997, what is the difference between the Aid flow from UN agencies (US$) in Fragile and conflict affected situations and Aid flow from UN agencies (US$) in Singapore?
Offer a very short reply. 4.90e+07. In the year 1997, what is the difference between the Aid flow from UN agencies (US$) of Fragile and conflict affected situations and Aid flow from UN agencies (US$) of Tanzania?
Ensure brevity in your answer.  4.72e+07. In the year 1997, what is the difference between the Aid flow from UN agencies (US$) of Libya and Aid flow from UN agencies (US$) of Singapore?
Provide a short and direct response. 1.31e+06. In the year 1997, what is the difference between the Aid flow from UN agencies (US$) of Libya and Aid flow from UN agencies (US$) of Tanzania?
Keep it short and to the point. -4.90e+05. In the year 1997, what is the difference between the Aid flow from UN agencies (US$) of Singapore and Aid flow from UN agencies (US$) of Tanzania?
Your answer should be compact. -1.80e+06. In the year 1998, what is the difference between the Aid flow from UN agencies (US$) in Fragile and conflict affected situations and Aid flow from UN agencies (US$) in Libya?
Keep it short and to the point. 4.34e+07. In the year 1998, what is the difference between the Aid flow from UN agencies (US$) in Fragile and conflict affected situations and Aid flow from UN agencies (US$) in Singapore?
Your response must be concise. 4.47e+07. In the year 1998, what is the difference between the Aid flow from UN agencies (US$) of Fragile and conflict affected situations and Aid flow from UN agencies (US$) of Tanzania?
Provide a short and direct response. 4.41e+07. In the year 1998, what is the difference between the Aid flow from UN agencies (US$) of Libya and Aid flow from UN agencies (US$) of Singapore?
Give a very brief answer. 1.32e+06. In the year 1998, what is the difference between the Aid flow from UN agencies (US$) in Singapore and Aid flow from UN agencies (US$) in Tanzania?
Your answer should be compact. -6.20e+05. What is the ratio of the Aid flow from UN agencies (US$) of Fragile and conflict affected situations in 1992 to that in 1993?
Your response must be concise. 0.95. What is the ratio of the Aid flow from UN agencies (US$) in Libya in 1992 to that in 1993?
Provide a succinct answer. 0.7. What is the ratio of the Aid flow from UN agencies (US$) of Singapore in 1992 to that in 1993?
Offer a very short reply. 1.36. What is the ratio of the Aid flow from UN agencies (US$) in Tanzania in 1992 to that in 1993?
Offer a terse response. 0.45. What is the ratio of the Aid flow from UN agencies (US$) of Fragile and conflict affected situations in 1992 to that in 1994?
Ensure brevity in your answer.  0.31. What is the ratio of the Aid flow from UN agencies (US$) of Libya in 1992 to that in 1994?
Provide a short and direct response. 0.68. What is the ratio of the Aid flow from UN agencies (US$) in Singapore in 1992 to that in 1994?
Make the answer very short. 1.03. What is the ratio of the Aid flow from UN agencies (US$) of Tanzania in 1992 to that in 1994?
Your answer should be compact. 0.04. What is the ratio of the Aid flow from UN agencies (US$) in Fragile and conflict affected situations in 1992 to that in 1995?
Give a very brief answer. 0.5. What is the ratio of the Aid flow from UN agencies (US$) of Libya in 1992 to that in 1995?
Your response must be concise. 0.65. What is the ratio of the Aid flow from UN agencies (US$) of Tanzania in 1992 to that in 1995?
Provide a short and direct response. 0.96. What is the ratio of the Aid flow from UN agencies (US$) of Fragile and conflict affected situations in 1992 to that in 1996?
Give a very brief answer. 1.78. What is the ratio of the Aid flow from UN agencies (US$) in Libya in 1992 to that in 1996?
Give a very brief answer. 0.58. What is the ratio of the Aid flow from UN agencies (US$) in Singapore in 1992 to that in 1996?
Give a very brief answer. 2.61. What is the ratio of the Aid flow from UN agencies (US$) of Tanzania in 1992 to that in 1996?
Keep it short and to the point. 0.41. What is the ratio of the Aid flow from UN agencies (US$) of Fragile and conflict affected situations in 1992 to that in 1997?
Your answer should be compact. 1.95. What is the ratio of the Aid flow from UN agencies (US$) in Libya in 1992 to that in 1997?
Your response must be concise. 0.53. What is the ratio of the Aid flow from UN agencies (US$) of Singapore in 1992 to that in 1997?
Your response must be concise. 8.57. What is the ratio of the Aid flow from UN agencies (US$) in Tanzania in 1992 to that in 1997?
Give a very brief answer. 1.17. What is the ratio of the Aid flow from UN agencies (US$) in Fragile and conflict affected situations in 1992 to that in 1998?
Your response must be concise. 2.13. What is the ratio of the Aid flow from UN agencies (US$) in Libya in 1992 to that in 1998?
Keep it short and to the point. 0.53. What is the ratio of the Aid flow from UN agencies (US$) in Singapore in 1992 to that in 1998?
Your answer should be very brief. 8.57. What is the ratio of the Aid flow from UN agencies (US$) in Tanzania in 1992 to that in 1998?
Offer a terse response. 3.17. What is the ratio of the Aid flow from UN agencies (US$) in Fragile and conflict affected situations in 1993 to that in 1994?
Offer a terse response. 0.33. What is the ratio of the Aid flow from UN agencies (US$) of Libya in 1993 to that in 1994?
Give a very brief answer. 0.98. What is the ratio of the Aid flow from UN agencies (US$) of Singapore in 1993 to that in 1994?
Provide a succinct answer. 0.76. What is the ratio of the Aid flow from UN agencies (US$) in Tanzania in 1993 to that in 1994?
Your answer should be compact. 0.1. What is the ratio of the Aid flow from UN agencies (US$) of Fragile and conflict affected situations in 1993 to that in 1995?
Ensure brevity in your answer.  0.53. What is the ratio of the Aid flow from UN agencies (US$) of Libya in 1993 to that in 1995?
Your answer should be compact. 0.93. What is the ratio of the Aid flow from UN agencies (US$) in Singapore in 1993 to that in 1995?
Ensure brevity in your answer.  1.47. What is the ratio of the Aid flow from UN agencies (US$) of Tanzania in 1993 to that in 1995?
Ensure brevity in your answer.  2.13. What is the ratio of the Aid flow from UN agencies (US$) of Fragile and conflict affected situations in 1993 to that in 1996?
Offer a very short reply. 1.88. What is the ratio of the Aid flow from UN agencies (US$) of Libya in 1993 to that in 1996?
Your answer should be compact. 0.84. What is the ratio of the Aid flow from UN agencies (US$) of Singapore in 1993 to that in 1996?
Ensure brevity in your answer.  1.91. What is the ratio of the Aid flow from UN agencies (US$) of Tanzania in 1993 to that in 1996?
Offer a very short reply. 0.9. What is the ratio of the Aid flow from UN agencies (US$) in Fragile and conflict affected situations in 1993 to that in 1997?
Give a very brief answer. 2.05. What is the ratio of the Aid flow from UN agencies (US$) in Libya in 1993 to that in 1997?
Your answer should be compact. 0.76. What is the ratio of the Aid flow from UN agencies (US$) of Singapore in 1993 to that in 1997?
Your response must be concise. 6.29. What is the ratio of the Aid flow from UN agencies (US$) of Tanzania in 1993 to that in 1997?
Offer a very short reply. 2.59. What is the ratio of the Aid flow from UN agencies (US$) in Fragile and conflict affected situations in 1993 to that in 1998?
Provide a succinct answer. 2.25. What is the ratio of the Aid flow from UN agencies (US$) of Libya in 1993 to that in 1998?
Ensure brevity in your answer.  0.76. What is the ratio of the Aid flow from UN agencies (US$) in Singapore in 1993 to that in 1998?
Your response must be concise. 6.29. What is the ratio of the Aid flow from UN agencies (US$) of Tanzania in 1993 to that in 1998?
Provide a succinct answer. 7.03. What is the ratio of the Aid flow from UN agencies (US$) of Fragile and conflict affected situations in 1994 to that in 1995?
Give a very brief answer. 1.62. What is the ratio of the Aid flow from UN agencies (US$) of Libya in 1994 to that in 1995?
Your answer should be compact. 0.95. What is the ratio of the Aid flow from UN agencies (US$) in Singapore in 1994 to that in 1995?
Your answer should be compact. 1.93. What is the ratio of the Aid flow from UN agencies (US$) of Tanzania in 1994 to that in 1995?
Your answer should be compact. 21.43. What is the ratio of the Aid flow from UN agencies (US$) in Fragile and conflict affected situations in 1994 to that in 1996?
Offer a terse response. 5.73. What is the ratio of the Aid flow from UN agencies (US$) in Libya in 1994 to that in 1996?
Your response must be concise. 0.86. What is the ratio of the Aid flow from UN agencies (US$) in Singapore in 1994 to that in 1996?
Your answer should be compact. 2.52. What is the ratio of the Aid flow from UN agencies (US$) in Tanzania in 1994 to that in 1996?
Ensure brevity in your answer.  9.1. What is the ratio of the Aid flow from UN agencies (US$) in Fragile and conflict affected situations in 1994 to that in 1997?
Your response must be concise. 6.25. What is the ratio of the Aid flow from UN agencies (US$) of Libya in 1994 to that in 1997?
Ensure brevity in your answer.  0.78. What is the ratio of the Aid flow from UN agencies (US$) in Singapore in 1994 to that in 1997?
Provide a short and direct response. 8.29. What is the ratio of the Aid flow from UN agencies (US$) in Tanzania in 1994 to that in 1997?
Your answer should be very brief. 26.13. What is the ratio of the Aid flow from UN agencies (US$) in Fragile and conflict affected situations in 1994 to that in 1998?
Provide a succinct answer. 6.85. What is the ratio of the Aid flow from UN agencies (US$) of Libya in 1994 to that in 1998?
Give a very brief answer. 0.77. What is the ratio of the Aid flow from UN agencies (US$) of Singapore in 1994 to that in 1998?
Ensure brevity in your answer.  8.29. What is the ratio of the Aid flow from UN agencies (US$) in Tanzania in 1994 to that in 1998?
Your answer should be very brief. 70.83. What is the ratio of the Aid flow from UN agencies (US$) in Fragile and conflict affected situations in 1995 to that in 1996?
Ensure brevity in your answer.  3.54. What is the ratio of the Aid flow from UN agencies (US$) in Libya in 1995 to that in 1996?
Provide a short and direct response. 0.9. What is the ratio of the Aid flow from UN agencies (US$) in Singapore in 1995 to that in 1996?
Your response must be concise. 1.3. What is the ratio of the Aid flow from UN agencies (US$) in Tanzania in 1995 to that in 1996?
Your answer should be very brief. 0.42. What is the ratio of the Aid flow from UN agencies (US$) in Fragile and conflict affected situations in 1995 to that in 1997?
Provide a succinct answer. 3.86. What is the ratio of the Aid flow from UN agencies (US$) of Libya in 1995 to that in 1997?
Give a very brief answer. 0.82. What is the ratio of the Aid flow from UN agencies (US$) in Singapore in 1995 to that in 1997?
Your answer should be compact. 4.29. What is the ratio of the Aid flow from UN agencies (US$) of Tanzania in 1995 to that in 1997?
Provide a short and direct response. 1.22. What is the ratio of the Aid flow from UN agencies (US$) of Fragile and conflict affected situations in 1995 to that in 1998?
Your answer should be compact. 4.23. What is the ratio of the Aid flow from UN agencies (US$) of Libya in 1995 to that in 1998?
Give a very brief answer. 0.81. What is the ratio of the Aid flow from UN agencies (US$) of Singapore in 1995 to that in 1998?
Make the answer very short. 4.29. What is the ratio of the Aid flow from UN agencies (US$) in Tanzania in 1995 to that in 1998?
Ensure brevity in your answer.  3.3. What is the ratio of the Aid flow from UN agencies (US$) of Fragile and conflict affected situations in 1996 to that in 1997?
Your answer should be compact. 1.09. What is the ratio of the Aid flow from UN agencies (US$) of Libya in 1996 to that in 1997?
Ensure brevity in your answer.  0.91. What is the ratio of the Aid flow from UN agencies (US$) in Singapore in 1996 to that in 1997?
Make the answer very short. 3.29. What is the ratio of the Aid flow from UN agencies (US$) of Tanzania in 1996 to that in 1997?
Provide a succinct answer. 2.87. What is the ratio of the Aid flow from UN agencies (US$) of Fragile and conflict affected situations in 1996 to that in 1998?
Your answer should be compact. 1.2. What is the ratio of the Aid flow from UN agencies (US$) in Libya in 1996 to that in 1998?
Your answer should be very brief. 0.9. What is the ratio of the Aid flow from UN agencies (US$) in Singapore in 1996 to that in 1998?
Your answer should be compact. 3.29. What is the ratio of the Aid flow from UN agencies (US$) in Tanzania in 1996 to that in 1998?
Keep it short and to the point. 7.78. What is the ratio of the Aid flow from UN agencies (US$) of Fragile and conflict affected situations in 1997 to that in 1998?
Provide a succinct answer. 1.1. What is the ratio of the Aid flow from UN agencies (US$) in Tanzania in 1997 to that in 1998?
Ensure brevity in your answer.  2.71. What is the difference between the highest and the second highest Aid flow from UN agencies (US$) in Fragile and conflict affected situations?
Offer a very short reply. 1.17e+08. What is the difference between the highest and the second highest Aid flow from UN agencies (US$) of Tanzania?
Keep it short and to the point. 4.35e+07. What is the difference between the highest and the lowest Aid flow from UN agencies (US$) in Fragile and conflict affected situations?
Your response must be concise. 2.62e+08. What is the difference between the highest and the lowest Aid flow from UN agencies (US$) in Libya?
Provide a succinct answer. 6.60e+05. What is the difference between the highest and the lowest Aid flow from UN agencies (US$) in Singapore?
Your answer should be compact. 5.30e+05. What is the difference between the highest and the lowest Aid flow from UN agencies (US$) in Tanzania?
Ensure brevity in your answer.  4.82e+07. 